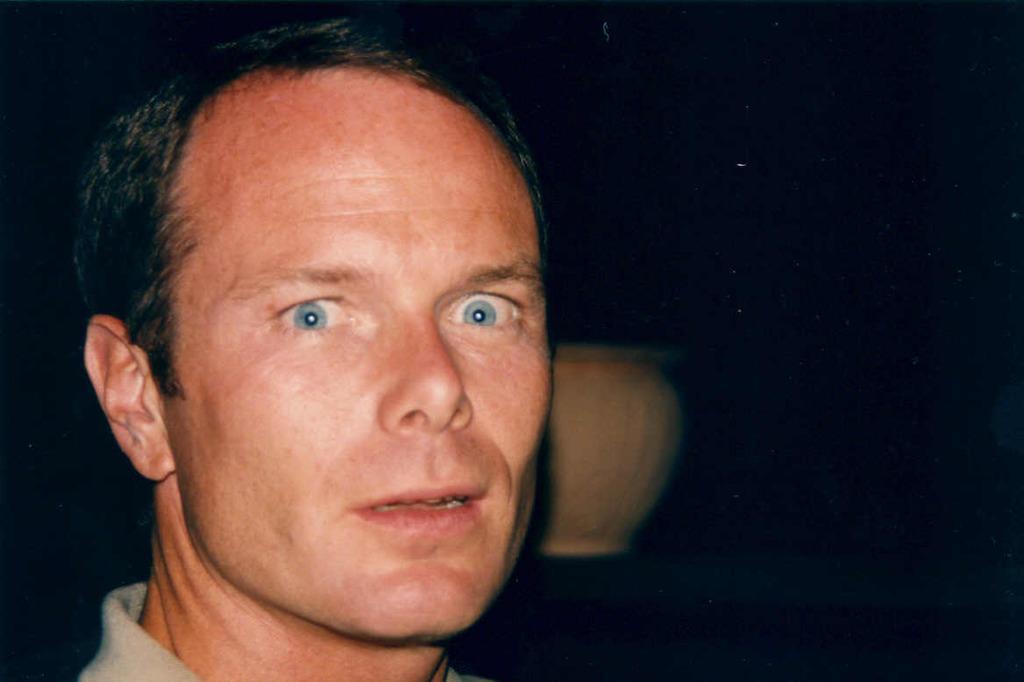In one or two sentences, can you explain what this image depicts? There is a man. In the back there is a pot. In the background it is dark. 